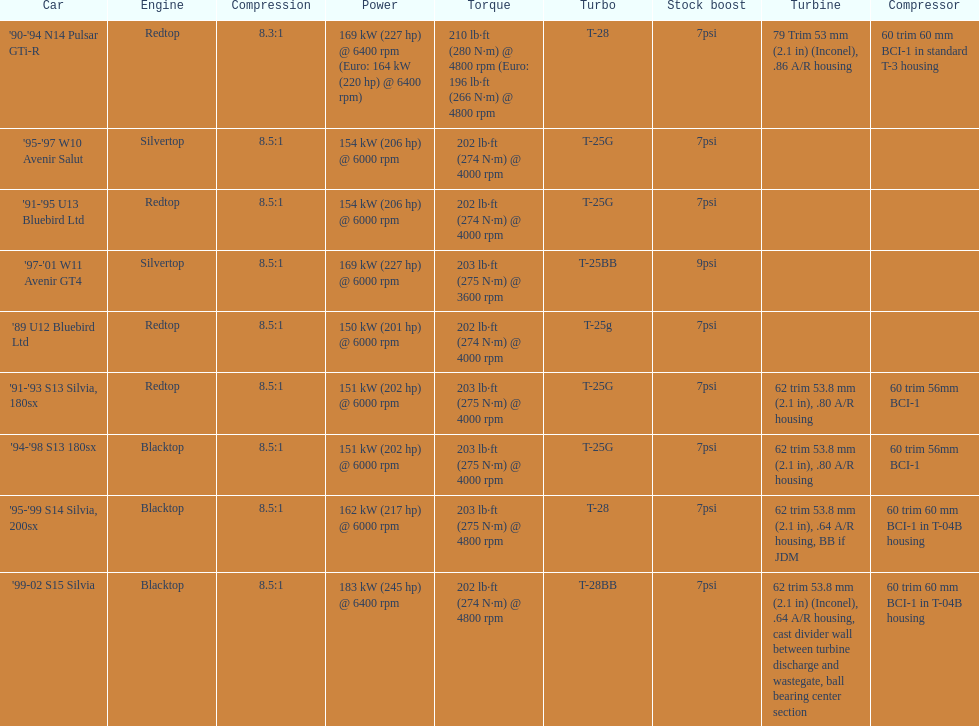Which car has a stock boost of over 7psi? '97-'01 W11 Avenir GT4. 